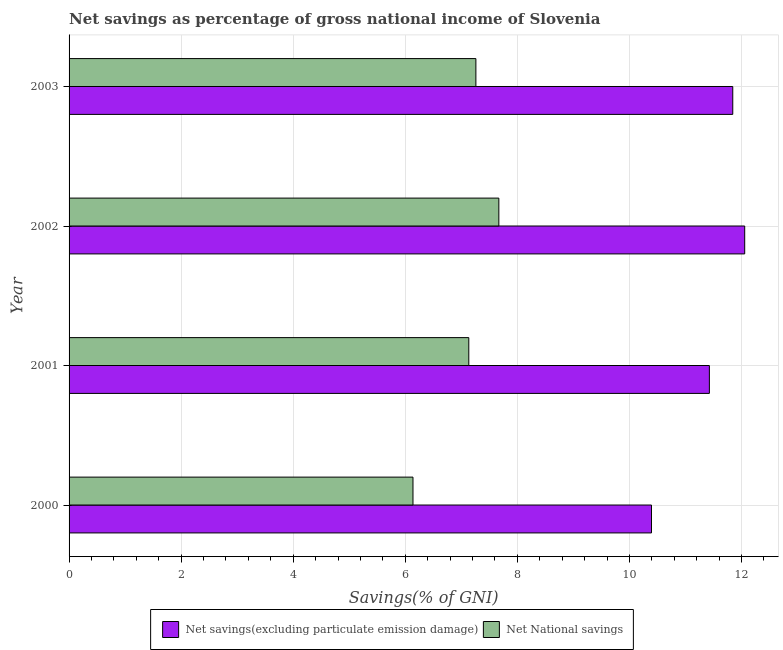How many groups of bars are there?
Provide a succinct answer. 4. Are the number of bars on each tick of the Y-axis equal?
Offer a terse response. Yes. What is the label of the 1st group of bars from the top?
Provide a short and direct response. 2003. In how many cases, is the number of bars for a given year not equal to the number of legend labels?
Provide a succinct answer. 0. What is the net national savings in 2000?
Keep it short and to the point. 6.14. Across all years, what is the maximum net national savings?
Provide a short and direct response. 7.67. Across all years, what is the minimum net savings(excluding particulate emission damage)?
Offer a very short reply. 10.39. In which year was the net savings(excluding particulate emission damage) minimum?
Your response must be concise. 2000. What is the total net savings(excluding particulate emission damage) in the graph?
Offer a terse response. 45.72. What is the difference between the net national savings in 2000 and that in 2002?
Your answer should be compact. -1.53. What is the difference between the net savings(excluding particulate emission damage) in 2002 and the net national savings in 2001?
Make the answer very short. 4.92. What is the average net national savings per year?
Keep it short and to the point. 7.05. In the year 2000, what is the difference between the net national savings and net savings(excluding particulate emission damage)?
Provide a succinct answer. -4.26. Is the net national savings in 2000 less than that in 2003?
Give a very brief answer. Yes. What is the difference between the highest and the second highest net national savings?
Provide a short and direct response. 0.41. What is the difference between the highest and the lowest net savings(excluding particulate emission damage)?
Ensure brevity in your answer.  1.66. Is the sum of the net national savings in 2000 and 2003 greater than the maximum net savings(excluding particulate emission damage) across all years?
Give a very brief answer. Yes. What does the 2nd bar from the top in 2002 represents?
Your answer should be very brief. Net savings(excluding particulate emission damage). What does the 1st bar from the bottom in 2000 represents?
Your answer should be compact. Net savings(excluding particulate emission damage). How many years are there in the graph?
Provide a succinct answer. 4. Are the values on the major ticks of X-axis written in scientific E-notation?
Offer a terse response. No. Does the graph contain any zero values?
Keep it short and to the point. No. How many legend labels are there?
Offer a very short reply. 2. What is the title of the graph?
Your answer should be compact. Net savings as percentage of gross national income of Slovenia. Does "Automatic Teller Machines" appear as one of the legend labels in the graph?
Your answer should be compact. No. What is the label or title of the X-axis?
Offer a terse response. Savings(% of GNI). What is the Savings(% of GNI) in Net savings(excluding particulate emission damage) in 2000?
Offer a very short reply. 10.39. What is the Savings(% of GNI) of Net National savings in 2000?
Provide a succinct answer. 6.14. What is the Savings(% of GNI) in Net savings(excluding particulate emission damage) in 2001?
Give a very brief answer. 11.43. What is the Savings(% of GNI) of Net National savings in 2001?
Provide a succinct answer. 7.13. What is the Savings(% of GNI) of Net savings(excluding particulate emission damage) in 2002?
Make the answer very short. 12.06. What is the Savings(% of GNI) in Net National savings in 2002?
Keep it short and to the point. 7.67. What is the Savings(% of GNI) in Net savings(excluding particulate emission damage) in 2003?
Your answer should be very brief. 11.84. What is the Savings(% of GNI) in Net National savings in 2003?
Your answer should be very brief. 7.26. Across all years, what is the maximum Savings(% of GNI) of Net savings(excluding particulate emission damage)?
Your response must be concise. 12.06. Across all years, what is the maximum Savings(% of GNI) of Net National savings?
Give a very brief answer. 7.67. Across all years, what is the minimum Savings(% of GNI) in Net savings(excluding particulate emission damage)?
Give a very brief answer. 10.39. Across all years, what is the minimum Savings(% of GNI) of Net National savings?
Keep it short and to the point. 6.14. What is the total Savings(% of GNI) in Net savings(excluding particulate emission damage) in the graph?
Offer a terse response. 45.72. What is the total Savings(% of GNI) of Net National savings in the graph?
Provide a short and direct response. 28.2. What is the difference between the Savings(% of GNI) in Net savings(excluding particulate emission damage) in 2000 and that in 2001?
Your answer should be compact. -1.03. What is the difference between the Savings(% of GNI) of Net National savings in 2000 and that in 2001?
Provide a short and direct response. -1. What is the difference between the Savings(% of GNI) of Net savings(excluding particulate emission damage) in 2000 and that in 2002?
Your answer should be very brief. -1.66. What is the difference between the Savings(% of GNI) in Net National savings in 2000 and that in 2002?
Offer a very short reply. -1.53. What is the difference between the Savings(% of GNI) in Net savings(excluding particulate emission damage) in 2000 and that in 2003?
Provide a succinct answer. -1.45. What is the difference between the Savings(% of GNI) of Net National savings in 2000 and that in 2003?
Offer a very short reply. -1.12. What is the difference between the Savings(% of GNI) in Net savings(excluding particulate emission damage) in 2001 and that in 2002?
Offer a terse response. -0.63. What is the difference between the Savings(% of GNI) in Net National savings in 2001 and that in 2002?
Keep it short and to the point. -0.54. What is the difference between the Savings(% of GNI) in Net savings(excluding particulate emission damage) in 2001 and that in 2003?
Your response must be concise. -0.42. What is the difference between the Savings(% of GNI) of Net National savings in 2001 and that in 2003?
Your answer should be compact. -0.13. What is the difference between the Savings(% of GNI) of Net savings(excluding particulate emission damage) in 2002 and that in 2003?
Provide a short and direct response. 0.21. What is the difference between the Savings(% of GNI) in Net National savings in 2002 and that in 2003?
Offer a very short reply. 0.41. What is the difference between the Savings(% of GNI) of Net savings(excluding particulate emission damage) in 2000 and the Savings(% of GNI) of Net National savings in 2001?
Make the answer very short. 3.26. What is the difference between the Savings(% of GNI) in Net savings(excluding particulate emission damage) in 2000 and the Savings(% of GNI) in Net National savings in 2002?
Offer a terse response. 2.72. What is the difference between the Savings(% of GNI) of Net savings(excluding particulate emission damage) in 2000 and the Savings(% of GNI) of Net National savings in 2003?
Your response must be concise. 3.13. What is the difference between the Savings(% of GNI) in Net savings(excluding particulate emission damage) in 2001 and the Savings(% of GNI) in Net National savings in 2002?
Provide a short and direct response. 3.76. What is the difference between the Savings(% of GNI) in Net savings(excluding particulate emission damage) in 2001 and the Savings(% of GNI) in Net National savings in 2003?
Make the answer very short. 4.17. What is the difference between the Savings(% of GNI) in Net savings(excluding particulate emission damage) in 2002 and the Savings(% of GNI) in Net National savings in 2003?
Make the answer very short. 4.8. What is the average Savings(% of GNI) of Net savings(excluding particulate emission damage) per year?
Your answer should be compact. 11.43. What is the average Savings(% of GNI) in Net National savings per year?
Your answer should be compact. 7.05. In the year 2000, what is the difference between the Savings(% of GNI) in Net savings(excluding particulate emission damage) and Savings(% of GNI) in Net National savings?
Offer a terse response. 4.26. In the year 2001, what is the difference between the Savings(% of GNI) of Net savings(excluding particulate emission damage) and Savings(% of GNI) of Net National savings?
Make the answer very short. 4.29. In the year 2002, what is the difference between the Savings(% of GNI) of Net savings(excluding particulate emission damage) and Savings(% of GNI) of Net National savings?
Your answer should be compact. 4.39. In the year 2003, what is the difference between the Savings(% of GNI) in Net savings(excluding particulate emission damage) and Savings(% of GNI) in Net National savings?
Your answer should be very brief. 4.58. What is the ratio of the Savings(% of GNI) of Net savings(excluding particulate emission damage) in 2000 to that in 2001?
Provide a succinct answer. 0.91. What is the ratio of the Savings(% of GNI) in Net National savings in 2000 to that in 2001?
Keep it short and to the point. 0.86. What is the ratio of the Savings(% of GNI) of Net savings(excluding particulate emission damage) in 2000 to that in 2002?
Your response must be concise. 0.86. What is the ratio of the Savings(% of GNI) of Net National savings in 2000 to that in 2002?
Provide a short and direct response. 0.8. What is the ratio of the Savings(% of GNI) of Net savings(excluding particulate emission damage) in 2000 to that in 2003?
Your answer should be very brief. 0.88. What is the ratio of the Savings(% of GNI) in Net National savings in 2000 to that in 2003?
Offer a terse response. 0.85. What is the ratio of the Savings(% of GNI) of Net savings(excluding particulate emission damage) in 2001 to that in 2002?
Your response must be concise. 0.95. What is the ratio of the Savings(% of GNI) of Net National savings in 2001 to that in 2002?
Your answer should be very brief. 0.93. What is the ratio of the Savings(% of GNI) in Net savings(excluding particulate emission damage) in 2001 to that in 2003?
Make the answer very short. 0.96. What is the ratio of the Savings(% of GNI) in Net National savings in 2001 to that in 2003?
Give a very brief answer. 0.98. What is the ratio of the Savings(% of GNI) in Net National savings in 2002 to that in 2003?
Offer a terse response. 1.06. What is the difference between the highest and the second highest Savings(% of GNI) of Net savings(excluding particulate emission damage)?
Your response must be concise. 0.21. What is the difference between the highest and the second highest Savings(% of GNI) of Net National savings?
Provide a short and direct response. 0.41. What is the difference between the highest and the lowest Savings(% of GNI) in Net savings(excluding particulate emission damage)?
Your response must be concise. 1.66. What is the difference between the highest and the lowest Savings(% of GNI) of Net National savings?
Keep it short and to the point. 1.53. 